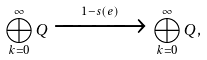Convert formula to latex. <formula><loc_0><loc_0><loc_500><loc_500>\bigoplus _ { k = 0 } ^ { \infty } Q \xrightarrow { 1 - s ( e ) } \bigoplus _ { k = 0 } ^ { \infty } Q ,</formula> 